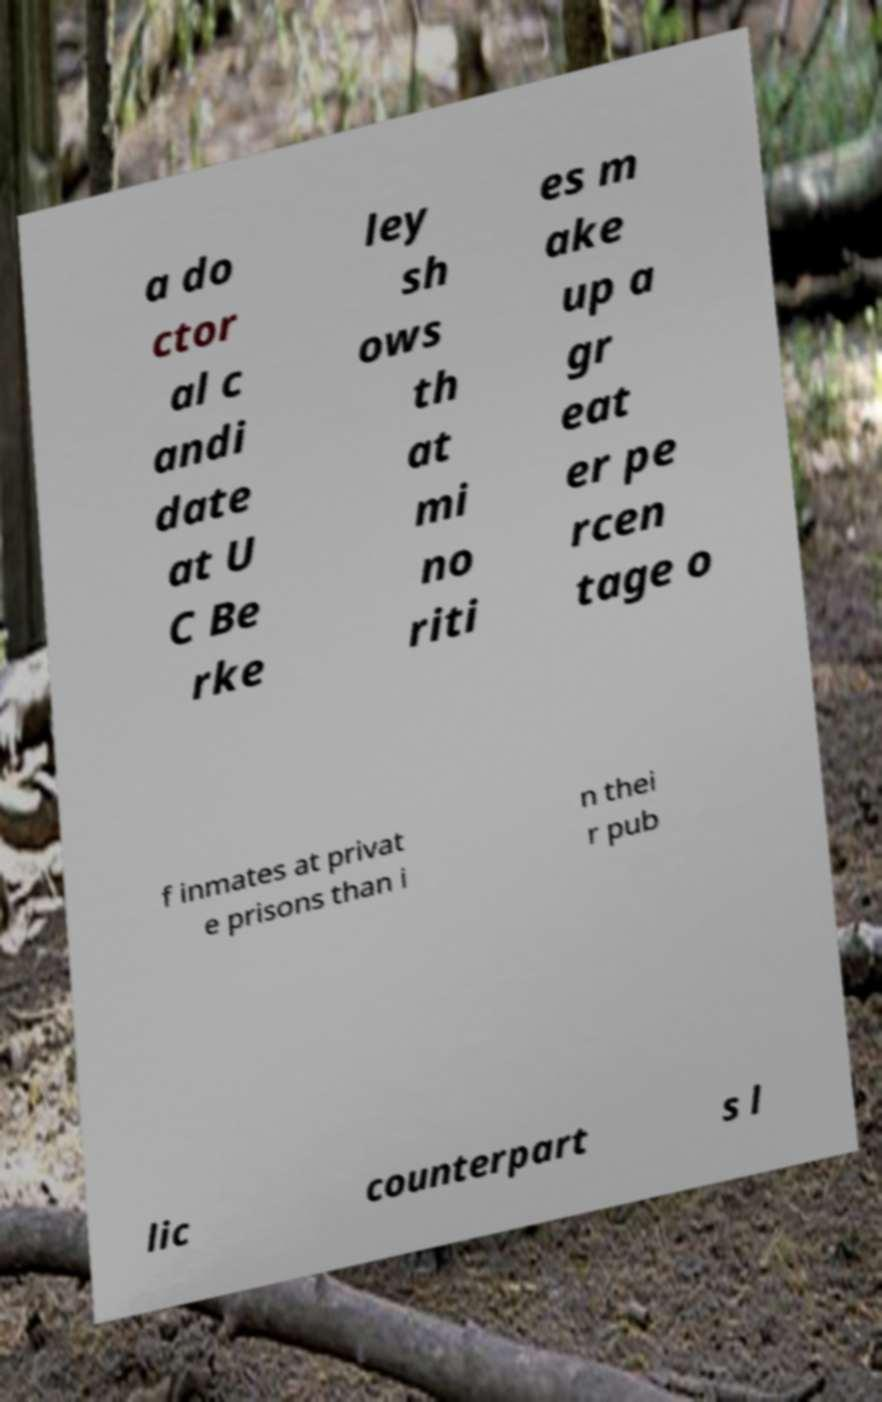There's text embedded in this image that I need extracted. Can you transcribe it verbatim? a do ctor al c andi date at U C Be rke ley sh ows th at mi no riti es m ake up a gr eat er pe rcen tage o f inmates at privat e prisons than i n thei r pub lic counterpart s l 